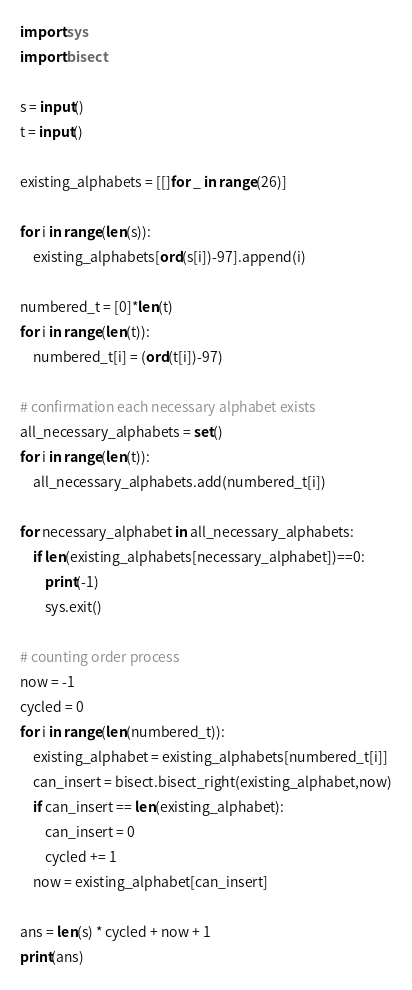<code> <loc_0><loc_0><loc_500><loc_500><_Python_>
import sys
import bisect

s = input()
t = input()

existing_alphabets = [[]for _ in range(26)]

for i in range(len(s)):
    existing_alphabets[ord(s[i])-97].append(i)

numbered_t = [0]*len(t)
for i in range(len(t)):
    numbered_t[i] = (ord(t[i])-97)

# confirmation each necessary alphabet exists
all_necessary_alphabets = set()
for i in range(len(t)):
    all_necessary_alphabets.add(numbered_t[i])

for necessary_alphabet in all_necessary_alphabets:
    if len(existing_alphabets[necessary_alphabet])==0:
        print(-1)
        sys.exit()

# counting order process
now = -1
cycled = 0
for i in range(len(numbered_t)):
    existing_alphabet = existing_alphabets[numbered_t[i]]
    can_insert = bisect.bisect_right(existing_alphabet,now)
    if can_insert == len(existing_alphabet):
        can_insert = 0
        cycled += 1
    now = existing_alphabet[can_insert]

ans = len(s) * cycled + now + 1
print(ans)</code> 